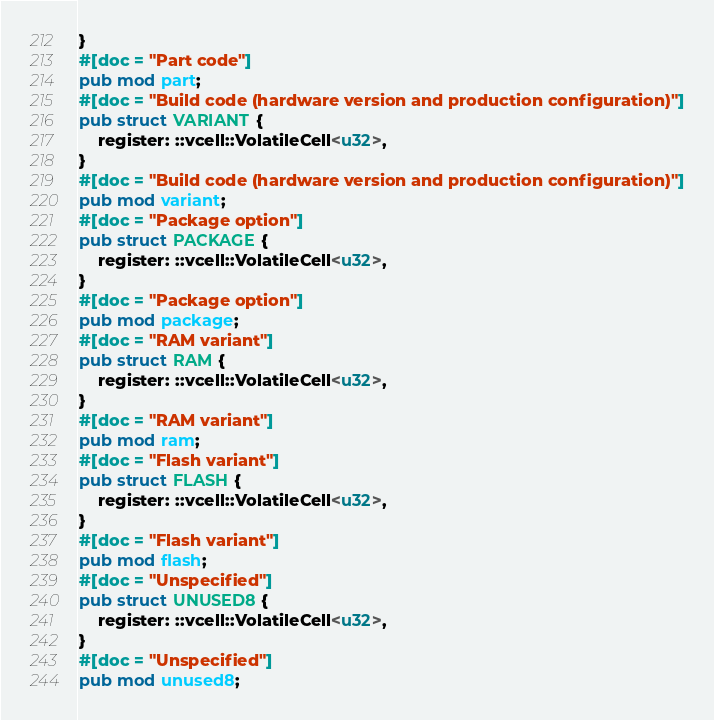<code> <loc_0><loc_0><loc_500><loc_500><_Rust_>}
#[doc = "Part code"]
pub mod part;
#[doc = "Build code (hardware version and production configuration)"]
pub struct VARIANT {
    register: ::vcell::VolatileCell<u32>,
}
#[doc = "Build code (hardware version and production configuration)"]
pub mod variant;
#[doc = "Package option"]
pub struct PACKAGE {
    register: ::vcell::VolatileCell<u32>,
}
#[doc = "Package option"]
pub mod package;
#[doc = "RAM variant"]
pub struct RAM {
    register: ::vcell::VolatileCell<u32>,
}
#[doc = "RAM variant"]
pub mod ram;
#[doc = "Flash variant"]
pub struct FLASH {
    register: ::vcell::VolatileCell<u32>,
}
#[doc = "Flash variant"]
pub mod flash;
#[doc = "Unspecified"]
pub struct UNUSED8 {
    register: ::vcell::VolatileCell<u32>,
}
#[doc = "Unspecified"]
pub mod unused8;
</code> 